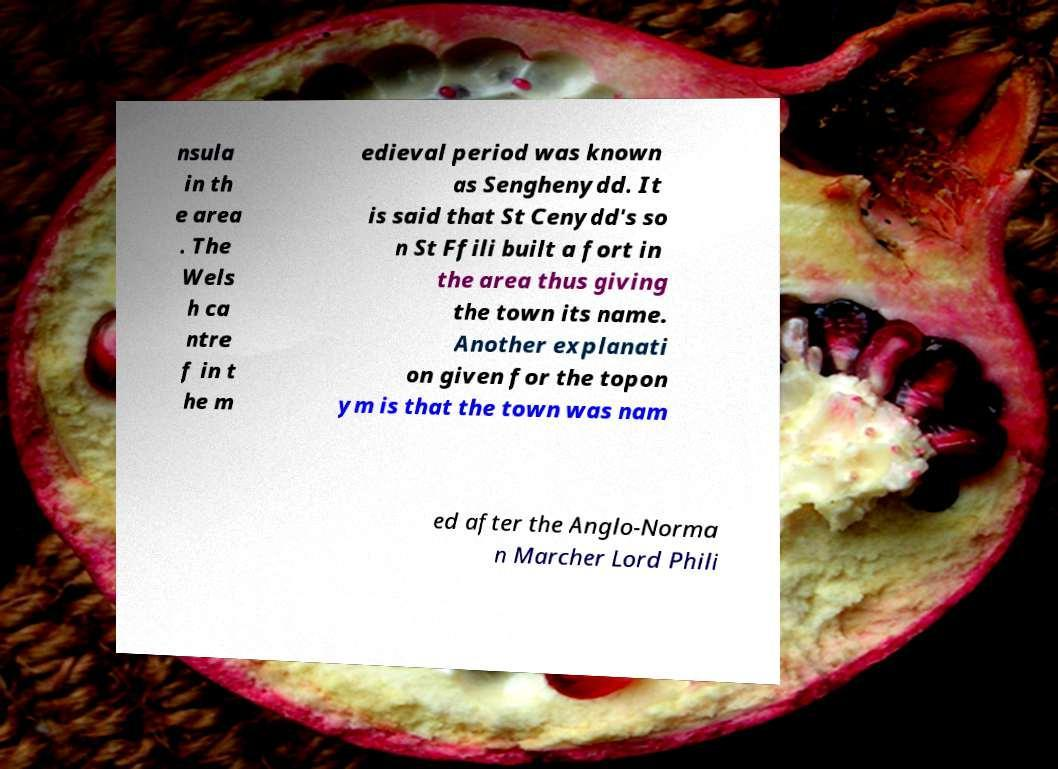Can you accurately transcribe the text from the provided image for me? nsula in th e area . The Wels h ca ntre f in t he m edieval period was known as Senghenydd. It is said that St Cenydd's so n St Ffili built a fort in the area thus giving the town its name. Another explanati on given for the topon ym is that the town was nam ed after the Anglo-Norma n Marcher Lord Phili 